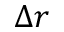<formula> <loc_0><loc_0><loc_500><loc_500>\Delta r</formula> 